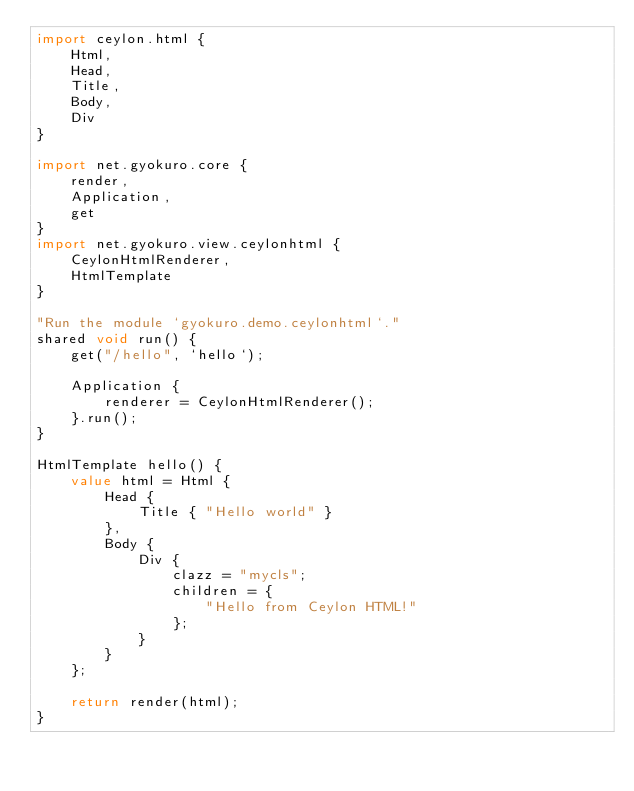<code> <loc_0><loc_0><loc_500><loc_500><_Ceylon_>import ceylon.html {
    Html,
    Head,
    Title,
    Body,
    Div
}

import net.gyokuro.core {
    render,
    Application,
    get
}
import net.gyokuro.view.ceylonhtml {
    CeylonHtmlRenderer,
    HtmlTemplate
}

"Run the module `gyokuro.demo.ceylonhtml`."
shared void run() {
    get("/hello", `hello`);
    
    Application {
        renderer = CeylonHtmlRenderer();
    }.run();
}

HtmlTemplate hello() {
    value html = Html {
        Head {
            Title { "Hello world" }
        },
        Body {
            Div {
                clazz = "mycls";
                children = {
                    "Hello from Ceylon HTML!"
                };
            }
        }
    };
    
    return render(html);
}
</code> 